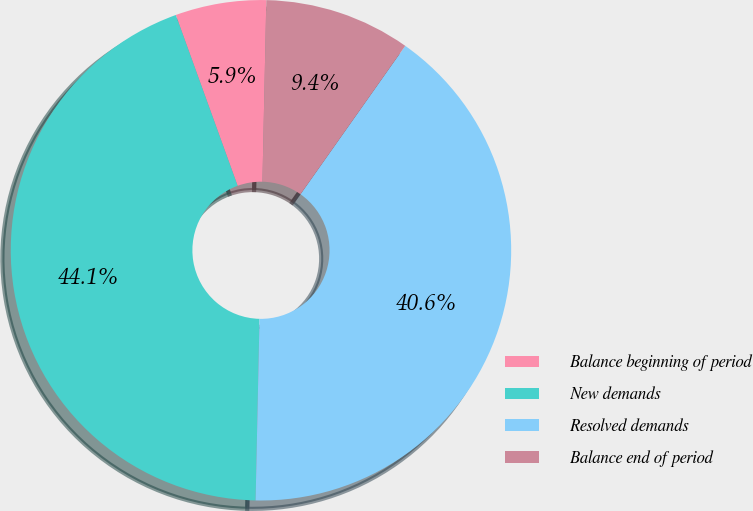Convert chart. <chart><loc_0><loc_0><loc_500><loc_500><pie_chart><fcel>Balance beginning of period<fcel>New demands<fcel>Resolved demands<fcel>Balance end of period<nl><fcel>5.87%<fcel>44.13%<fcel>40.56%<fcel>9.44%<nl></chart> 